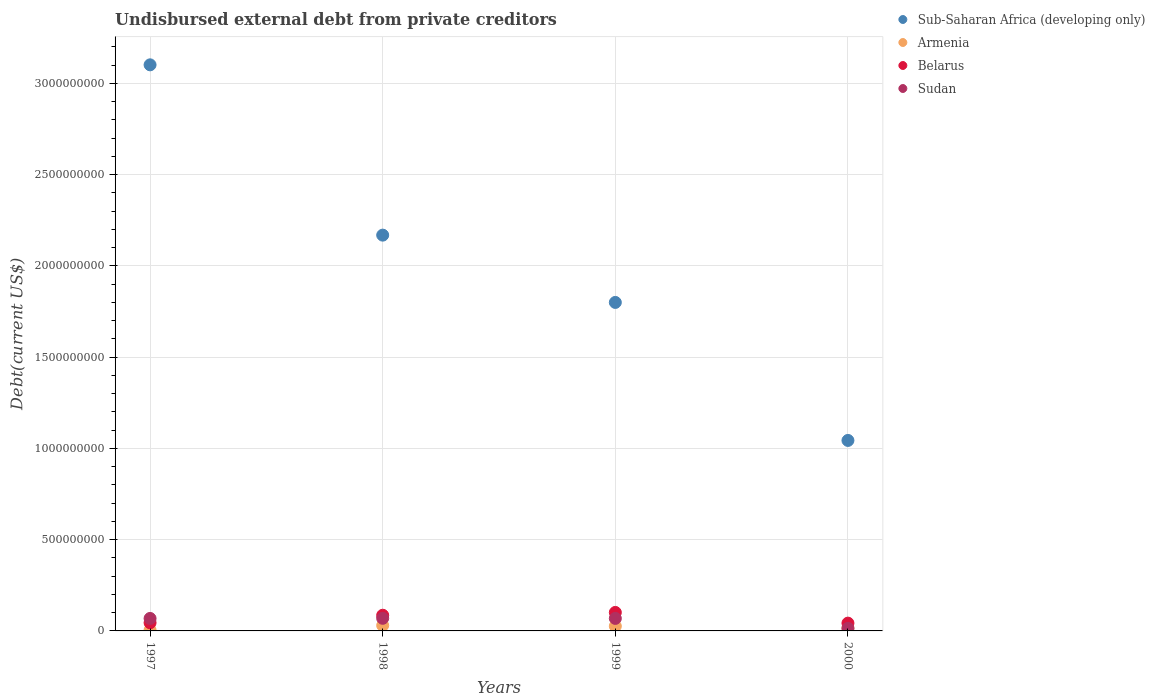How many different coloured dotlines are there?
Offer a terse response. 4. What is the total debt in Belarus in 2000?
Provide a short and direct response. 4.27e+07. Across all years, what is the maximum total debt in Sudan?
Provide a short and direct response. 6.92e+07. Across all years, what is the minimum total debt in Sub-Saharan Africa (developing only)?
Your answer should be very brief. 1.04e+09. In which year was the total debt in Belarus minimum?
Make the answer very short. 2000. What is the total total debt in Belarus in the graph?
Your answer should be compact. 2.75e+08. What is the difference between the total debt in Sub-Saharan Africa (developing only) in 1998 and that in 2000?
Your answer should be very brief. 1.13e+09. What is the difference between the total debt in Armenia in 1997 and the total debt in Belarus in 1999?
Your answer should be very brief. -9.63e+07. What is the average total debt in Belarus per year?
Offer a very short reply. 6.86e+07. In the year 1999, what is the difference between the total debt in Armenia and total debt in Sub-Saharan Africa (developing only)?
Make the answer very short. -1.77e+09. What is the ratio of the total debt in Sub-Saharan Africa (developing only) in 1997 to that in 1998?
Make the answer very short. 1.43. What is the difference between the highest and the second highest total debt in Belarus?
Give a very brief answer. 1.54e+07. What is the difference between the highest and the lowest total debt in Armenia?
Give a very brief answer. 2.50e+07. In how many years, is the total debt in Belarus greater than the average total debt in Belarus taken over all years?
Provide a short and direct response. 2. Does the total debt in Sudan monotonically increase over the years?
Your answer should be compact. No. Is the total debt in Belarus strictly greater than the total debt in Sudan over the years?
Your response must be concise. No. How many dotlines are there?
Ensure brevity in your answer.  4. How many years are there in the graph?
Give a very brief answer. 4. What is the difference between two consecutive major ticks on the Y-axis?
Your answer should be very brief. 5.00e+08. Does the graph contain any zero values?
Provide a succinct answer. No. Does the graph contain grids?
Provide a succinct answer. Yes. Where does the legend appear in the graph?
Ensure brevity in your answer.  Top right. How many legend labels are there?
Give a very brief answer. 4. What is the title of the graph?
Provide a short and direct response. Undisbursed external debt from private creditors. What is the label or title of the Y-axis?
Your answer should be compact. Debt(current US$). What is the Debt(current US$) in Sub-Saharan Africa (developing only) in 1997?
Make the answer very short. 3.10e+09. What is the Debt(current US$) in Armenia in 1997?
Make the answer very short. 5.00e+06. What is the Debt(current US$) in Belarus in 1997?
Your answer should be very brief. 4.46e+07. What is the Debt(current US$) of Sudan in 1997?
Ensure brevity in your answer.  6.84e+07. What is the Debt(current US$) in Sub-Saharan Africa (developing only) in 1998?
Ensure brevity in your answer.  2.17e+09. What is the Debt(current US$) in Armenia in 1998?
Your response must be concise. 3.00e+07. What is the Debt(current US$) in Belarus in 1998?
Your response must be concise. 8.59e+07. What is the Debt(current US$) of Sudan in 1998?
Your answer should be compact. 6.92e+07. What is the Debt(current US$) of Sub-Saharan Africa (developing only) in 1999?
Give a very brief answer. 1.80e+09. What is the Debt(current US$) of Armenia in 1999?
Provide a short and direct response. 2.61e+07. What is the Debt(current US$) in Belarus in 1999?
Keep it short and to the point. 1.01e+08. What is the Debt(current US$) of Sudan in 1999?
Your response must be concise. 6.86e+07. What is the Debt(current US$) in Sub-Saharan Africa (developing only) in 2000?
Ensure brevity in your answer.  1.04e+09. What is the Debt(current US$) in Armenia in 2000?
Ensure brevity in your answer.  1.58e+07. What is the Debt(current US$) in Belarus in 2000?
Keep it short and to the point. 4.27e+07. What is the Debt(current US$) of Sudan in 2000?
Give a very brief answer. 1.38e+07. Across all years, what is the maximum Debt(current US$) in Sub-Saharan Africa (developing only)?
Your answer should be compact. 3.10e+09. Across all years, what is the maximum Debt(current US$) in Armenia?
Keep it short and to the point. 3.00e+07. Across all years, what is the maximum Debt(current US$) in Belarus?
Your answer should be compact. 1.01e+08. Across all years, what is the maximum Debt(current US$) of Sudan?
Provide a short and direct response. 6.92e+07. Across all years, what is the minimum Debt(current US$) of Sub-Saharan Africa (developing only)?
Provide a succinct answer. 1.04e+09. Across all years, what is the minimum Debt(current US$) in Armenia?
Provide a succinct answer. 5.00e+06. Across all years, what is the minimum Debt(current US$) of Belarus?
Provide a short and direct response. 4.27e+07. Across all years, what is the minimum Debt(current US$) in Sudan?
Your response must be concise. 1.38e+07. What is the total Debt(current US$) of Sub-Saharan Africa (developing only) in the graph?
Provide a short and direct response. 8.11e+09. What is the total Debt(current US$) in Armenia in the graph?
Keep it short and to the point. 7.69e+07. What is the total Debt(current US$) of Belarus in the graph?
Your answer should be compact. 2.75e+08. What is the total Debt(current US$) of Sudan in the graph?
Your answer should be very brief. 2.20e+08. What is the difference between the Debt(current US$) of Sub-Saharan Africa (developing only) in 1997 and that in 1998?
Keep it short and to the point. 9.33e+08. What is the difference between the Debt(current US$) of Armenia in 1997 and that in 1998?
Ensure brevity in your answer.  -2.50e+07. What is the difference between the Debt(current US$) in Belarus in 1997 and that in 1998?
Provide a short and direct response. -4.13e+07. What is the difference between the Debt(current US$) of Sudan in 1997 and that in 1998?
Offer a very short reply. -7.58e+05. What is the difference between the Debt(current US$) in Sub-Saharan Africa (developing only) in 1997 and that in 1999?
Provide a succinct answer. 1.30e+09. What is the difference between the Debt(current US$) in Armenia in 1997 and that in 1999?
Keep it short and to the point. -2.11e+07. What is the difference between the Debt(current US$) of Belarus in 1997 and that in 1999?
Ensure brevity in your answer.  -5.67e+07. What is the difference between the Debt(current US$) in Sudan in 1997 and that in 1999?
Make the answer very short. -1.63e+05. What is the difference between the Debt(current US$) in Sub-Saharan Africa (developing only) in 1997 and that in 2000?
Your response must be concise. 2.06e+09. What is the difference between the Debt(current US$) of Armenia in 1997 and that in 2000?
Your response must be concise. -1.08e+07. What is the difference between the Debt(current US$) of Belarus in 1997 and that in 2000?
Offer a very short reply. 1.90e+06. What is the difference between the Debt(current US$) of Sudan in 1997 and that in 2000?
Your answer should be compact. 5.46e+07. What is the difference between the Debt(current US$) of Sub-Saharan Africa (developing only) in 1998 and that in 1999?
Your response must be concise. 3.69e+08. What is the difference between the Debt(current US$) of Armenia in 1998 and that in 1999?
Keep it short and to the point. 3.90e+06. What is the difference between the Debt(current US$) of Belarus in 1998 and that in 1999?
Your response must be concise. -1.54e+07. What is the difference between the Debt(current US$) of Sudan in 1998 and that in 1999?
Make the answer very short. 5.95e+05. What is the difference between the Debt(current US$) of Sub-Saharan Africa (developing only) in 1998 and that in 2000?
Ensure brevity in your answer.  1.13e+09. What is the difference between the Debt(current US$) in Armenia in 1998 and that in 2000?
Your response must be concise. 1.42e+07. What is the difference between the Debt(current US$) in Belarus in 1998 and that in 2000?
Offer a terse response. 4.32e+07. What is the difference between the Debt(current US$) of Sudan in 1998 and that in 2000?
Keep it short and to the point. 5.54e+07. What is the difference between the Debt(current US$) of Sub-Saharan Africa (developing only) in 1999 and that in 2000?
Make the answer very short. 7.56e+08. What is the difference between the Debt(current US$) of Armenia in 1999 and that in 2000?
Offer a terse response. 1.04e+07. What is the difference between the Debt(current US$) of Belarus in 1999 and that in 2000?
Provide a succinct answer. 5.86e+07. What is the difference between the Debt(current US$) in Sudan in 1999 and that in 2000?
Your response must be concise. 5.48e+07. What is the difference between the Debt(current US$) in Sub-Saharan Africa (developing only) in 1997 and the Debt(current US$) in Armenia in 1998?
Offer a very short reply. 3.07e+09. What is the difference between the Debt(current US$) of Sub-Saharan Africa (developing only) in 1997 and the Debt(current US$) of Belarus in 1998?
Give a very brief answer. 3.02e+09. What is the difference between the Debt(current US$) of Sub-Saharan Africa (developing only) in 1997 and the Debt(current US$) of Sudan in 1998?
Your response must be concise. 3.03e+09. What is the difference between the Debt(current US$) of Armenia in 1997 and the Debt(current US$) of Belarus in 1998?
Offer a very short reply. -8.09e+07. What is the difference between the Debt(current US$) of Armenia in 1997 and the Debt(current US$) of Sudan in 1998?
Keep it short and to the point. -6.42e+07. What is the difference between the Debt(current US$) in Belarus in 1997 and the Debt(current US$) in Sudan in 1998?
Offer a terse response. -2.45e+07. What is the difference between the Debt(current US$) in Sub-Saharan Africa (developing only) in 1997 and the Debt(current US$) in Armenia in 1999?
Keep it short and to the point. 3.08e+09. What is the difference between the Debt(current US$) in Sub-Saharan Africa (developing only) in 1997 and the Debt(current US$) in Belarus in 1999?
Keep it short and to the point. 3.00e+09. What is the difference between the Debt(current US$) in Sub-Saharan Africa (developing only) in 1997 and the Debt(current US$) in Sudan in 1999?
Offer a terse response. 3.03e+09. What is the difference between the Debt(current US$) of Armenia in 1997 and the Debt(current US$) of Belarus in 1999?
Give a very brief answer. -9.63e+07. What is the difference between the Debt(current US$) of Armenia in 1997 and the Debt(current US$) of Sudan in 1999?
Offer a very short reply. -6.36e+07. What is the difference between the Debt(current US$) in Belarus in 1997 and the Debt(current US$) in Sudan in 1999?
Your response must be concise. -2.39e+07. What is the difference between the Debt(current US$) of Sub-Saharan Africa (developing only) in 1997 and the Debt(current US$) of Armenia in 2000?
Offer a terse response. 3.09e+09. What is the difference between the Debt(current US$) in Sub-Saharan Africa (developing only) in 1997 and the Debt(current US$) in Belarus in 2000?
Provide a succinct answer. 3.06e+09. What is the difference between the Debt(current US$) in Sub-Saharan Africa (developing only) in 1997 and the Debt(current US$) in Sudan in 2000?
Provide a succinct answer. 3.09e+09. What is the difference between the Debt(current US$) in Armenia in 1997 and the Debt(current US$) in Belarus in 2000?
Your answer should be compact. -3.77e+07. What is the difference between the Debt(current US$) in Armenia in 1997 and the Debt(current US$) in Sudan in 2000?
Give a very brief answer. -8.79e+06. What is the difference between the Debt(current US$) in Belarus in 1997 and the Debt(current US$) in Sudan in 2000?
Make the answer very short. 3.08e+07. What is the difference between the Debt(current US$) in Sub-Saharan Africa (developing only) in 1998 and the Debt(current US$) in Armenia in 1999?
Make the answer very short. 2.14e+09. What is the difference between the Debt(current US$) of Sub-Saharan Africa (developing only) in 1998 and the Debt(current US$) of Belarus in 1999?
Make the answer very short. 2.07e+09. What is the difference between the Debt(current US$) in Sub-Saharan Africa (developing only) in 1998 and the Debt(current US$) in Sudan in 1999?
Offer a terse response. 2.10e+09. What is the difference between the Debt(current US$) in Armenia in 1998 and the Debt(current US$) in Belarus in 1999?
Give a very brief answer. -7.13e+07. What is the difference between the Debt(current US$) in Armenia in 1998 and the Debt(current US$) in Sudan in 1999?
Offer a very short reply. -3.86e+07. What is the difference between the Debt(current US$) in Belarus in 1998 and the Debt(current US$) in Sudan in 1999?
Ensure brevity in your answer.  1.74e+07. What is the difference between the Debt(current US$) in Sub-Saharan Africa (developing only) in 1998 and the Debt(current US$) in Armenia in 2000?
Offer a terse response. 2.15e+09. What is the difference between the Debt(current US$) in Sub-Saharan Africa (developing only) in 1998 and the Debt(current US$) in Belarus in 2000?
Keep it short and to the point. 2.13e+09. What is the difference between the Debt(current US$) in Sub-Saharan Africa (developing only) in 1998 and the Debt(current US$) in Sudan in 2000?
Provide a short and direct response. 2.16e+09. What is the difference between the Debt(current US$) in Armenia in 1998 and the Debt(current US$) in Belarus in 2000?
Make the answer very short. -1.27e+07. What is the difference between the Debt(current US$) of Armenia in 1998 and the Debt(current US$) of Sudan in 2000?
Your response must be concise. 1.62e+07. What is the difference between the Debt(current US$) of Belarus in 1998 and the Debt(current US$) of Sudan in 2000?
Give a very brief answer. 7.21e+07. What is the difference between the Debt(current US$) of Sub-Saharan Africa (developing only) in 1999 and the Debt(current US$) of Armenia in 2000?
Offer a very short reply. 1.78e+09. What is the difference between the Debt(current US$) of Sub-Saharan Africa (developing only) in 1999 and the Debt(current US$) of Belarus in 2000?
Make the answer very short. 1.76e+09. What is the difference between the Debt(current US$) of Sub-Saharan Africa (developing only) in 1999 and the Debt(current US$) of Sudan in 2000?
Give a very brief answer. 1.79e+09. What is the difference between the Debt(current US$) in Armenia in 1999 and the Debt(current US$) in Belarus in 2000?
Keep it short and to the point. -1.66e+07. What is the difference between the Debt(current US$) of Armenia in 1999 and the Debt(current US$) of Sudan in 2000?
Provide a succinct answer. 1.23e+07. What is the difference between the Debt(current US$) of Belarus in 1999 and the Debt(current US$) of Sudan in 2000?
Provide a succinct answer. 8.75e+07. What is the average Debt(current US$) of Sub-Saharan Africa (developing only) per year?
Provide a succinct answer. 2.03e+09. What is the average Debt(current US$) of Armenia per year?
Provide a short and direct response. 1.92e+07. What is the average Debt(current US$) in Belarus per year?
Ensure brevity in your answer.  6.86e+07. What is the average Debt(current US$) of Sudan per year?
Make the answer very short. 5.50e+07. In the year 1997, what is the difference between the Debt(current US$) of Sub-Saharan Africa (developing only) and Debt(current US$) of Armenia?
Make the answer very short. 3.10e+09. In the year 1997, what is the difference between the Debt(current US$) of Sub-Saharan Africa (developing only) and Debt(current US$) of Belarus?
Offer a very short reply. 3.06e+09. In the year 1997, what is the difference between the Debt(current US$) in Sub-Saharan Africa (developing only) and Debt(current US$) in Sudan?
Give a very brief answer. 3.03e+09. In the year 1997, what is the difference between the Debt(current US$) in Armenia and Debt(current US$) in Belarus?
Your answer should be compact. -3.96e+07. In the year 1997, what is the difference between the Debt(current US$) of Armenia and Debt(current US$) of Sudan?
Your answer should be very brief. -6.34e+07. In the year 1997, what is the difference between the Debt(current US$) in Belarus and Debt(current US$) in Sudan?
Your answer should be very brief. -2.38e+07. In the year 1998, what is the difference between the Debt(current US$) of Sub-Saharan Africa (developing only) and Debt(current US$) of Armenia?
Your response must be concise. 2.14e+09. In the year 1998, what is the difference between the Debt(current US$) of Sub-Saharan Africa (developing only) and Debt(current US$) of Belarus?
Provide a succinct answer. 2.08e+09. In the year 1998, what is the difference between the Debt(current US$) in Sub-Saharan Africa (developing only) and Debt(current US$) in Sudan?
Provide a short and direct response. 2.10e+09. In the year 1998, what is the difference between the Debt(current US$) in Armenia and Debt(current US$) in Belarus?
Keep it short and to the point. -5.59e+07. In the year 1998, what is the difference between the Debt(current US$) in Armenia and Debt(current US$) in Sudan?
Your answer should be compact. -3.92e+07. In the year 1998, what is the difference between the Debt(current US$) in Belarus and Debt(current US$) in Sudan?
Your answer should be compact. 1.68e+07. In the year 1999, what is the difference between the Debt(current US$) of Sub-Saharan Africa (developing only) and Debt(current US$) of Armenia?
Provide a short and direct response. 1.77e+09. In the year 1999, what is the difference between the Debt(current US$) of Sub-Saharan Africa (developing only) and Debt(current US$) of Belarus?
Your response must be concise. 1.70e+09. In the year 1999, what is the difference between the Debt(current US$) of Sub-Saharan Africa (developing only) and Debt(current US$) of Sudan?
Ensure brevity in your answer.  1.73e+09. In the year 1999, what is the difference between the Debt(current US$) of Armenia and Debt(current US$) of Belarus?
Give a very brief answer. -7.52e+07. In the year 1999, what is the difference between the Debt(current US$) in Armenia and Debt(current US$) in Sudan?
Offer a very short reply. -4.25e+07. In the year 1999, what is the difference between the Debt(current US$) in Belarus and Debt(current US$) in Sudan?
Your answer should be very brief. 3.28e+07. In the year 2000, what is the difference between the Debt(current US$) of Sub-Saharan Africa (developing only) and Debt(current US$) of Armenia?
Offer a terse response. 1.03e+09. In the year 2000, what is the difference between the Debt(current US$) of Sub-Saharan Africa (developing only) and Debt(current US$) of Belarus?
Provide a short and direct response. 1.00e+09. In the year 2000, what is the difference between the Debt(current US$) in Sub-Saharan Africa (developing only) and Debt(current US$) in Sudan?
Make the answer very short. 1.03e+09. In the year 2000, what is the difference between the Debt(current US$) in Armenia and Debt(current US$) in Belarus?
Offer a terse response. -2.70e+07. In the year 2000, what is the difference between the Debt(current US$) in Armenia and Debt(current US$) in Sudan?
Give a very brief answer. 1.96e+06. In the year 2000, what is the difference between the Debt(current US$) in Belarus and Debt(current US$) in Sudan?
Give a very brief answer. 2.89e+07. What is the ratio of the Debt(current US$) of Sub-Saharan Africa (developing only) in 1997 to that in 1998?
Ensure brevity in your answer.  1.43. What is the ratio of the Debt(current US$) in Belarus in 1997 to that in 1998?
Offer a terse response. 0.52. What is the ratio of the Debt(current US$) of Sudan in 1997 to that in 1998?
Your answer should be compact. 0.99. What is the ratio of the Debt(current US$) of Sub-Saharan Africa (developing only) in 1997 to that in 1999?
Your response must be concise. 1.72. What is the ratio of the Debt(current US$) of Armenia in 1997 to that in 1999?
Make the answer very short. 0.19. What is the ratio of the Debt(current US$) of Belarus in 1997 to that in 1999?
Ensure brevity in your answer.  0.44. What is the ratio of the Debt(current US$) in Sub-Saharan Africa (developing only) in 1997 to that in 2000?
Your response must be concise. 2.97. What is the ratio of the Debt(current US$) in Armenia in 1997 to that in 2000?
Offer a terse response. 0.32. What is the ratio of the Debt(current US$) of Belarus in 1997 to that in 2000?
Your answer should be compact. 1.04. What is the ratio of the Debt(current US$) of Sudan in 1997 to that in 2000?
Provide a succinct answer. 4.96. What is the ratio of the Debt(current US$) of Sub-Saharan Africa (developing only) in 1998 to that in 1999?
Keep it short and to the point. 1.2. What is the ratio of the Debt(current US$) of Armenia in 1998 to that in 1999?
Provide a short and direct response. 1.15. What is the ratio of the Debt(current US$) in Belarus in 1998 to that in 1999?
Ensure brevity in your answer.  0.85. What is the ratio of the Debt(current US$) in Sudan in 1998 to that in 1999?
Provide a succinct answer. 1.01. What is the ratio of the Debt(current US$) of Sub-Saharan Africa (developing only) in 1998 to that in 2000?
Offer a terse response. 2.08. What is the ratio of the Debt(current US$) in Armenia in 1998 to that in 2000?
Your answer should be very brief. 1.9. What is the ratio of the Debt(current US$) of Belarus in 1998 to that in 2000?
Ensure brevity in your answer.  2.01. What is the ratio of the Debt(current US$) of Sudan in 1998 to that in 2000?
Your answer should be compact. 5.01. What is the ratio of the Debt(current US$) of Sub-Saharan Africa (developing only) in 1999 to that in 2000?
Provide a succinct answer. 1.72. What is the ratio of the Debt(current US$) of Armenia in 1999 to that in 2000?
Your answer should be very brief. 1.66. What is the ratio of the Debt(current US$) in Belarus in 1999 to that in 2000?
Your response must be concise. 2.37. What is the ratio of the Debt(current US$) of Sudan in 1999 to that in 2000?
Keep it short and to the point. 4.97. What is the difference between the highest and the second highest Debt(current US$) of Sub-Saharan Africa (developing only)?
Provide a succinct answer. 9.33e+08. What is the difference between the highest and the second highest Debt(current US$) of Armenia?
Ensure brevity in your answer.  3.90e+06. What is the difference between the highest and the second highest Debt(current US$) of Belarus?
Give a very brief answer. 1.54e+07. What is the difference between the highest and the second highest Debt(current US$) of Sudan?
Give a very brief answer. 5.95e+05. What is the difference between the highest and the lowest Debt(current US$) in Sub-Saharan Africa (developing only)?
Give a very brief answer. 2.06e+09. What is the difference between the highest and the lowest Debt(current US$) of Armenia?
Your answer should be compact. 2.50e+07. What is the difference between the highest and the lowest Debt(current US$) of Belarus?
Make the answer very short. 5.86e+07. What is the difference between the highest and the lowest Debt(current US$) in Sudan?
Offer a terse response. 5.54e+07. 